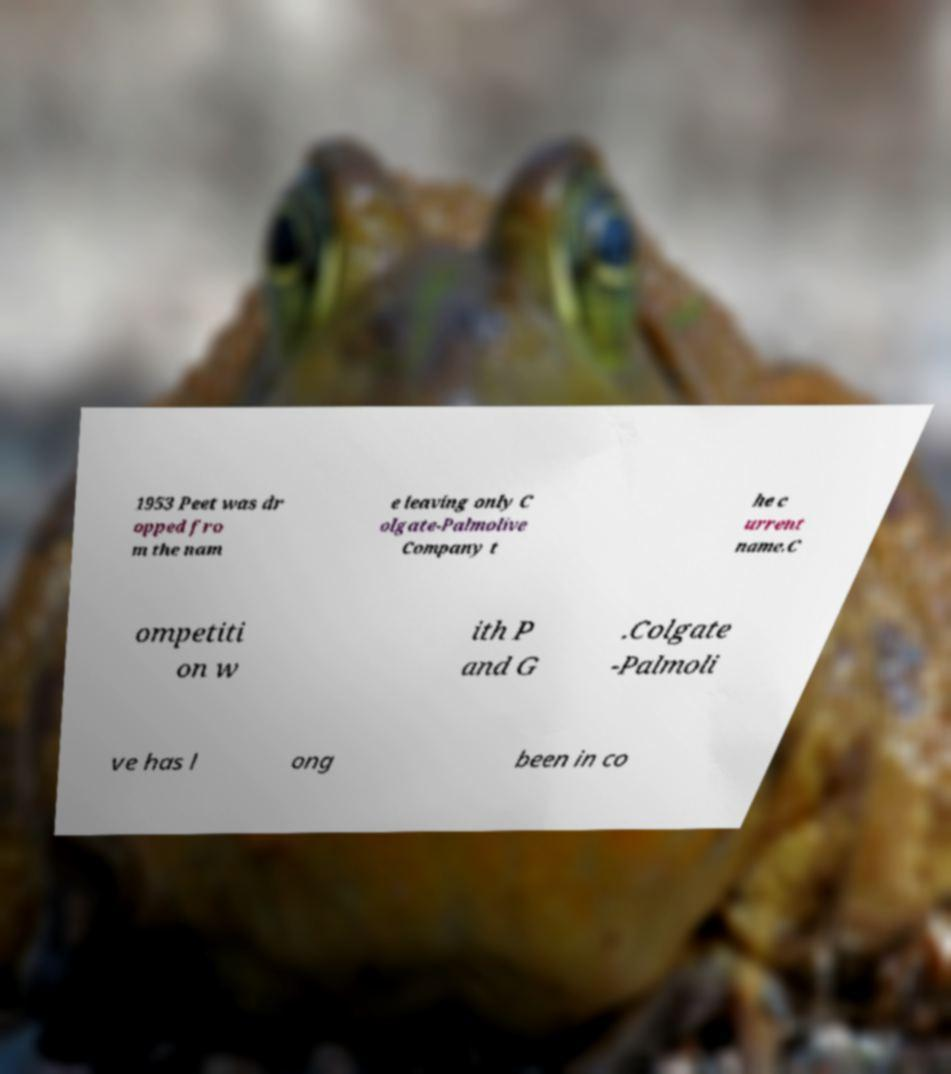Can you read and provide the text displayed in the image?This photo seems to have some interesting text. Can you extract and type it out for me? 1953 Peet was dr opped fro m the nam e leaving only C olgate-Palmolive Company t he c urrent name.C ompetiti on w ith P and G .Colgate -Palmoli ve has l ong been in co 